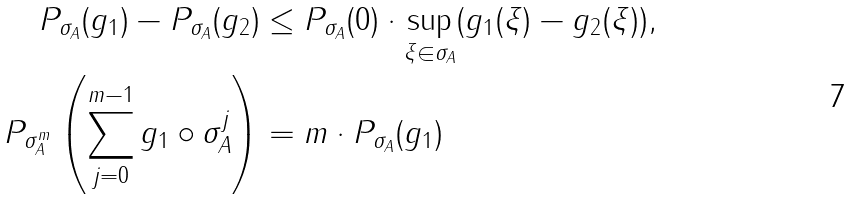<formula> <loc_0><loc_0><loc_500><loc_500>P _ { \sigma _ { A } } ( g _ { 1 } ) - P _ { \sigma _ { A } } ( g _ { 2 } ) & \leq P _ { \sigma _ { A } } ( 0 ) \cdot \sup _ { \xi \in \sigma _ { A } } ( g _ { 1 } ( \xi ) - g _ { 2 } ( \xi ) ) , \\ P _ { \sigma _ { A } ^ { m } } \left ( \sum _ { j = 0 } ^ { m - 1 } g _ { 1 } \circ \sigma _ { A } ^ { j } \right ) & = m \cdot P _ { \sigma _ { A } } ( g _ { 1 } )</formula> 